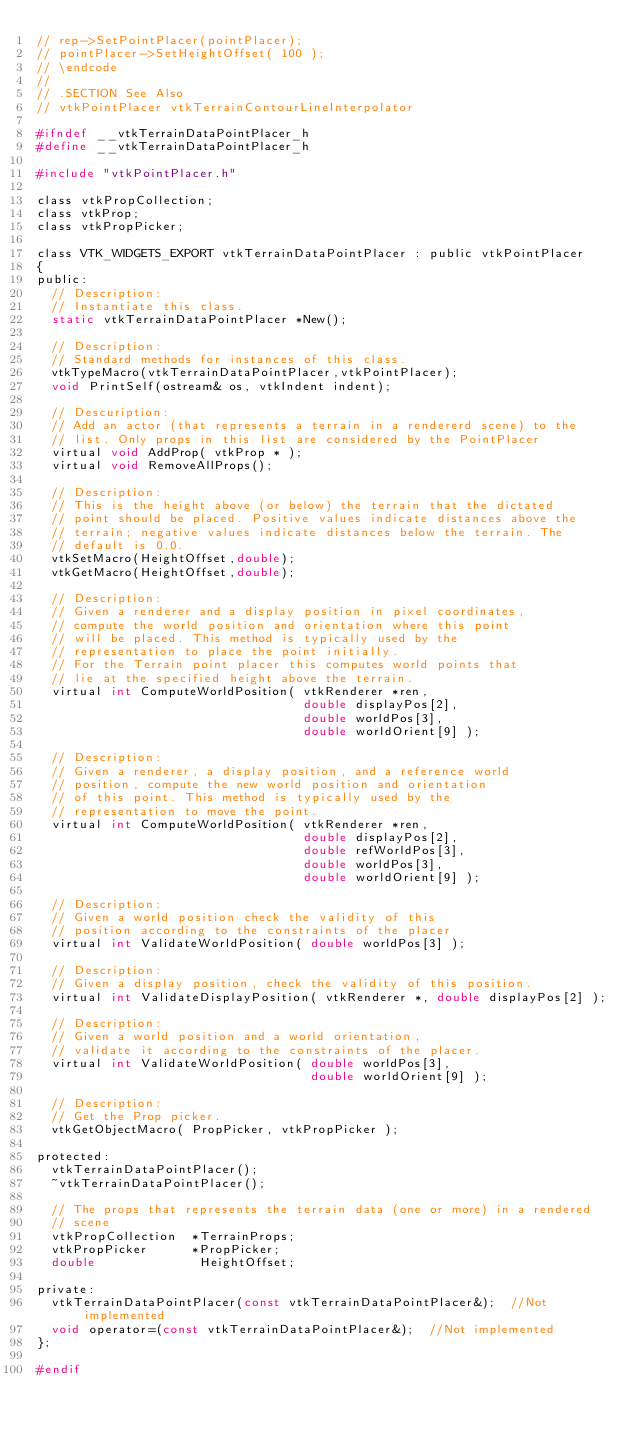Convert code to text. <code><loc_0><loc_0><loc_500><loc_500><_C_>// rep->SetPointPlacer(pointPlacer);
// pointPlacer->SetHeightOffset( 100 );
// \endcode
//
// .SECTION See Also
// vtkPointPlacer vtkTerrainContourLineInterpolator

#ifndef __vtkTerrainDataPointPlacer_h
#define __vtkTerrainDataPointPlacer_h

#include "vtkPointPlacer.h"

class vtkPropCollection;
class vtkProp;
class vtkPropPicker;

class VTK_WIDGETS_EXPORT vtkTerrainDataPointPlacer : public vtkPointPlacer
{
public:
  // Description:
  // Instantiate this class.
  static vtkTerrainDataPointPlacer *New();

  // Description:
  // Standard methods for instances of this class.
  vtkTypeMacro(vtkTerrainDataPointPlacer,vtkPointPlacer);
  void PrintSelf(ostream& os, vtkIndent indent);

  // Descuription:
  // Add an actor (that represents a terrain in a rendererd scene) to the 
  // list. Only props in this list are considered by the PointPlacer
  virtual void AddProp( vtkProp * );
  virtual void RemoveAllProps();

  // Description:
  // This is the height above (or below) the terrain that the dictated
  // point should be placed. Positive values indicate distances above the 
  // terrain; negative values indicate distances below the terrain. The 
  // default is 0.0. 
  vtkSetMacro(HeightOffset,double);
  vtkGetMacro(HeightOffset,double);
  
  // Description:
  // Given a renderer and a display position in pixel coordinates,
  // compute the world position and orientation where this point
  // will be placed. This method is typically used by the
  // representation to place the point initially.
  // For the Terrain point placer this computes world points that
  // lie at the specified height above the terrain.
  virtual int ComputeWorldPosition( vtkRenderer *ren,
                                    double displayPos[2], 
                                    double worldPos[3],
                                    double worldOrient[9] );
  
  // Description:
  // Given a renderer, a display position, and a reference world
  // position, compute the new world position and orientation 
  // of this point. This method is typically used by the 
  // representation to move the point.
  virtual int ComputeWorldPosition( vtkRenderer *ren,
                                    double displayPos[2], 
                                    double refWorldPos[3],
                                    double worldPos[3],
                                    double worldOrient[9] );
  
  // Description:
  // Given a world position check the validity of this 
  // position according to the constraints of the placer
  virtual int ValidateWorldPosition( double worldPos[3] );
  
  // Description:
  // Given a display position, check the validity of this position.
  virtual int ValidateDisplayPosition( vtkRenderer *, double displayPos[2] );
  
  // Description:
  // Given a world position and a world orientation,
  // validate it according to the constraints of the placer.
  virtual int ValidateWorldPosition( double worldPos[3],
                                     double worldOrient[9] );

  // Description:
  // Get the Prop picker.
  vtkGetObjectMacro( PropPicker, vtkPropPicker );  

protected:
  vtkTerrainDataPointPlacer();
  ~vtkTerrainDataPointPlacer();

  // The props that represents the terrain data (one or more) in a rendered 
  // scene
  vtkPropCollection  *TerrainProps;
  vtkPropPicker      *PropPicker;
  double              HeightOffset;
  
private:
  vtkTerrainDataPointPlacer(const vtkTerrainDataPointPlacer&);  //Not implemented
  void operator=(const vtkTerrainDataPointPlacer&);  //Not implemented
};

#endif
</code> 